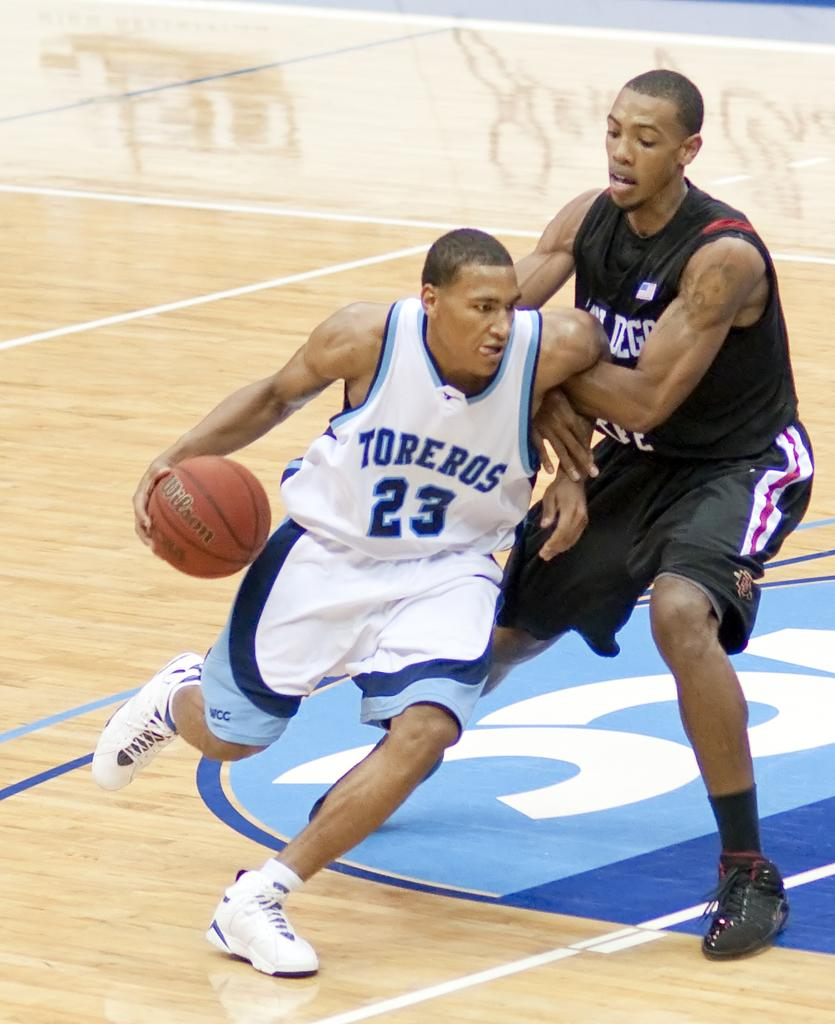<image>
Share a concise interpretation of the image provided. a person dribbling that has the number 23 on their jersey 